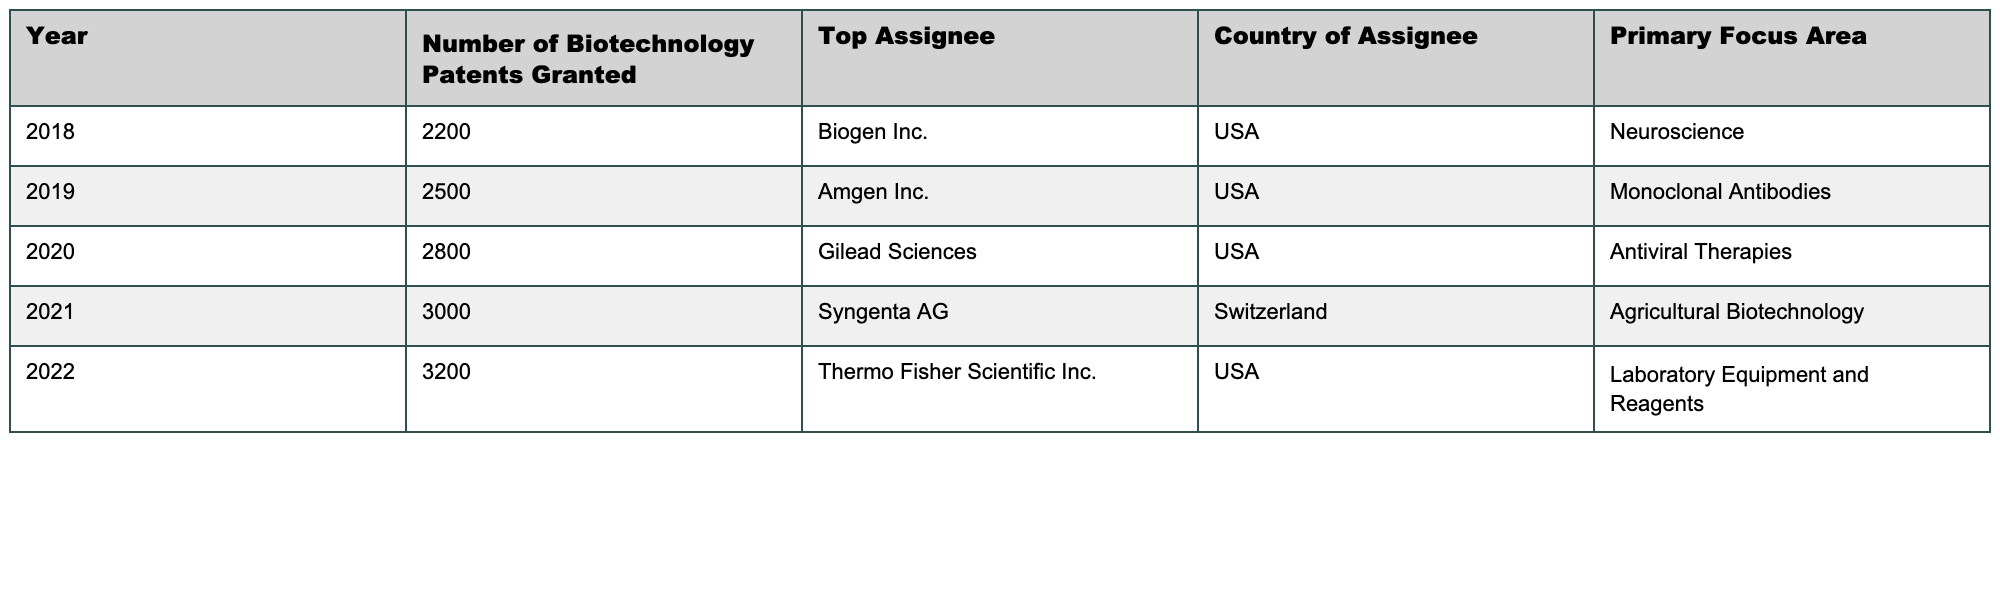What was the number of biotechnology patents granted in 2019? According to the table, the number of biotechnology patents granted in 2019 is directly listed as 2500.
Answer: 2500 Who was the top assignee for biotechnology patents in 2021? The table shows that the top assignee for biotechnology patents in 2021 is Syngenta AG.
Answer: Syngenta AG Which country had the top assignee for biotechnology patents in 2022? The table indicates that the top assignee in 2022 was Thermo Fisher Scientific Inc., which is based in the USA.
Answer: USA What is the primary focus area for the top assignee in 2020? The table lists Gilead Sciences as the top assignee in 2020, and their primary focus area is antiviral therapies.
Answer: Antiviral Therapies How many more biotechnology patents were granted in 2022 compared to 2018? The number of patents granted in 2022 is 3200, and in 2018 it is 2200. To find the difference, subtract 2200 from 3200, which is 1000.
Answer: 1000 What was the average number of biotechnology patents granted from 2018 to 2022? The numbers of patents are 2200, 2500, 2800, 3000, and 3200. To find the average, add them together (2200 + 2500 + 2800 + 3000 + 3200) to get 13700, then divide by 5, which equals 2740.
Answer: 2740 Did Switzerland have a top assignee for biotechnology patents in any year? The table lists Syngenta AG, based in Switzerland, as the top assignee in 2021, confirming they were an assignee in that year.
Answer: Yes Which year saw the highest number of biotechnology patents granted? By reviewing the table, it is clear that 2022 had the highest number of biotechnology patents granted, with a total of 3200.
Answer: 2022 Which primary focus area had the least number of patents granted in the table? Comparing the primary focus areas listed, the area with the least number of patents granted is neuroscience in 2018 with 2200 patents.
Answer: Neuroscience If we combine the patents granted for 2019 and 2021, how many patents were granted altogether? Add the number of patents for 2019 (2500) with those granted in 2021 (3000), resulting in a total of 5500 patents granted altogether.
Answer: 5500 